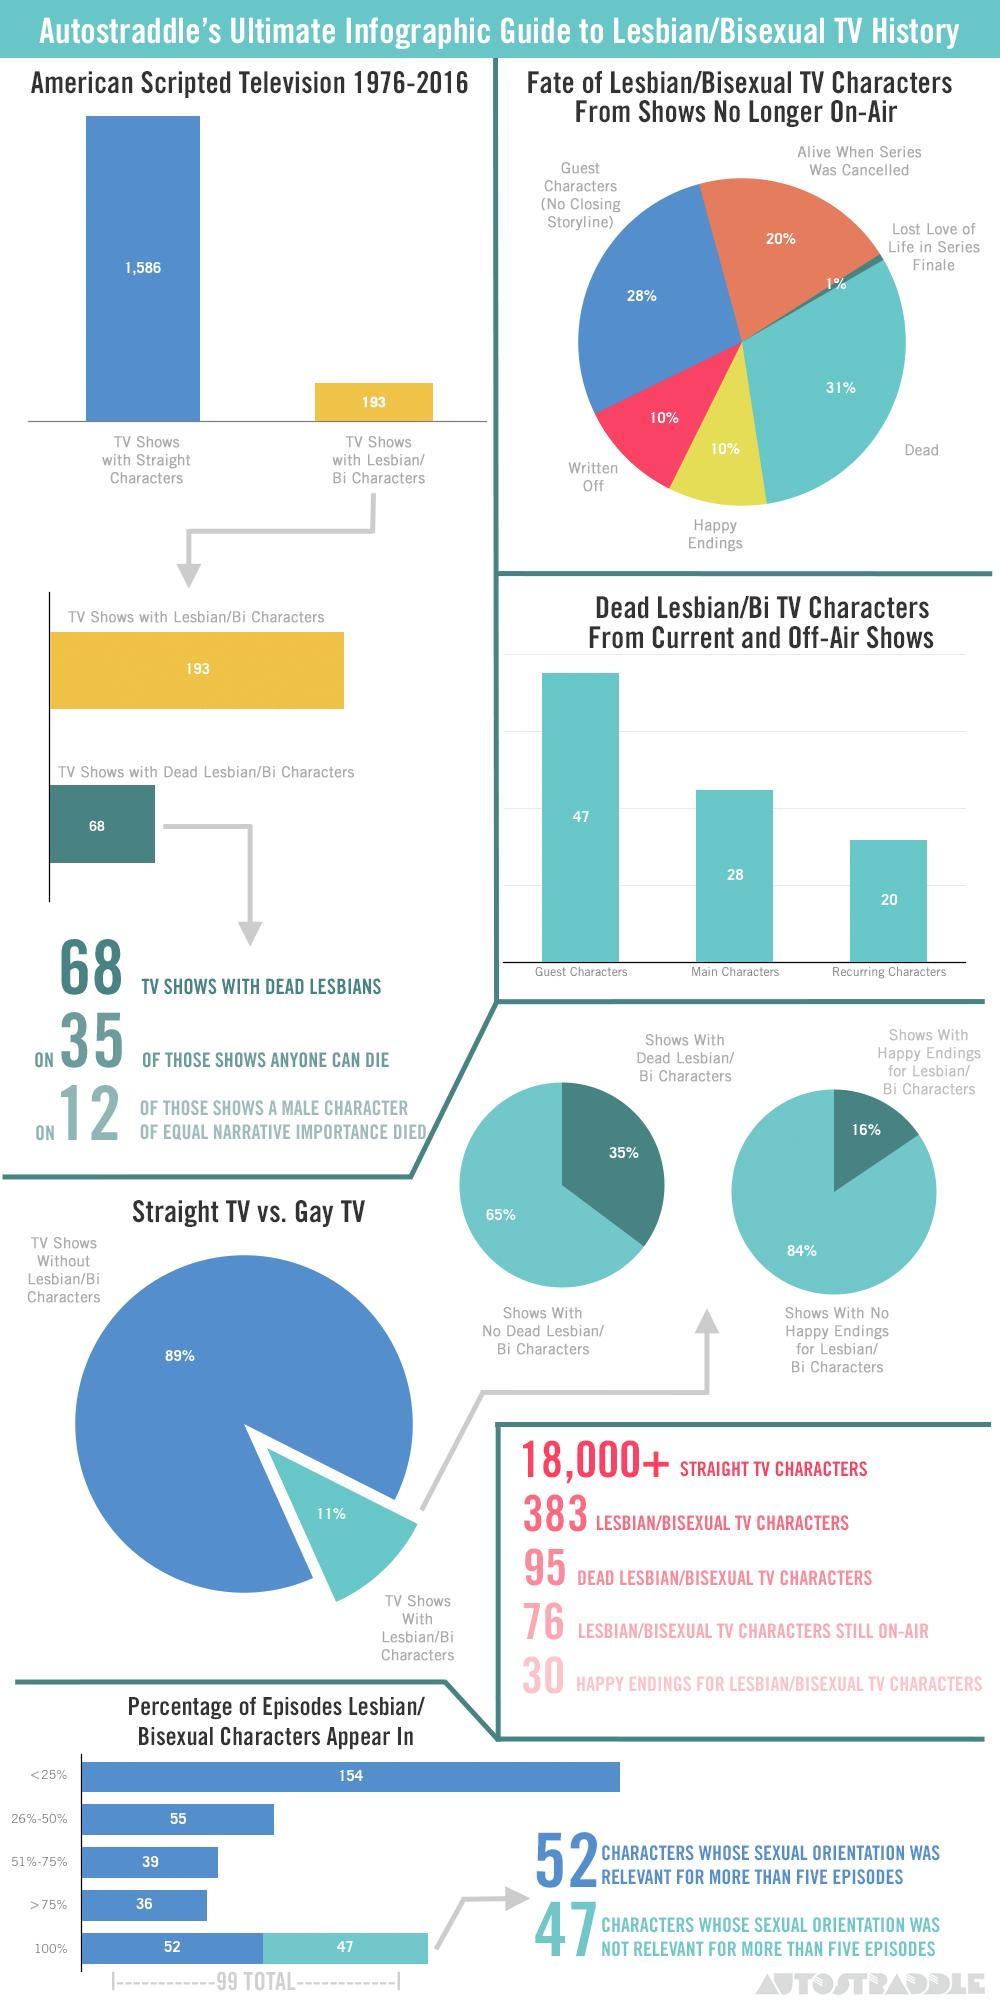List a handful of essential elements in this visual. Approximately 20% of lesbian/bisexual TV characters from shows that are no longer on-air were still alive when the series was cancelled. The study found that 10% of lesbian/bisexual TV characters from shows no longer on-air had happy endings, indicating a lack of representation and positive outcomes for LGBTQ+ characters on television. The research found that 38% of lesbian/bisexual TV characters from shows that are no longer on-air were either written off or were guest characters. The percentage of shows with dead lesbian/bisexual characters is 30% lower than the shows with no dead lesbian/bisexual characters. Approximately 10% of lesbian/bisexual TV characters from shows no longer on-air were written off. 